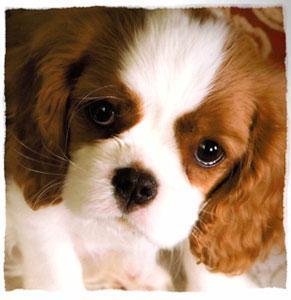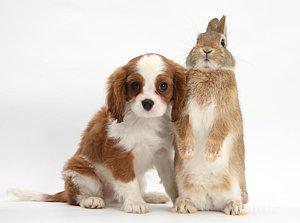The first image is the image on the left, the second image is the image on the right. Analyze the images presented: Is the assertion "A rabbit is with at least one puppy." valid? Answer yes or no. Yes. 